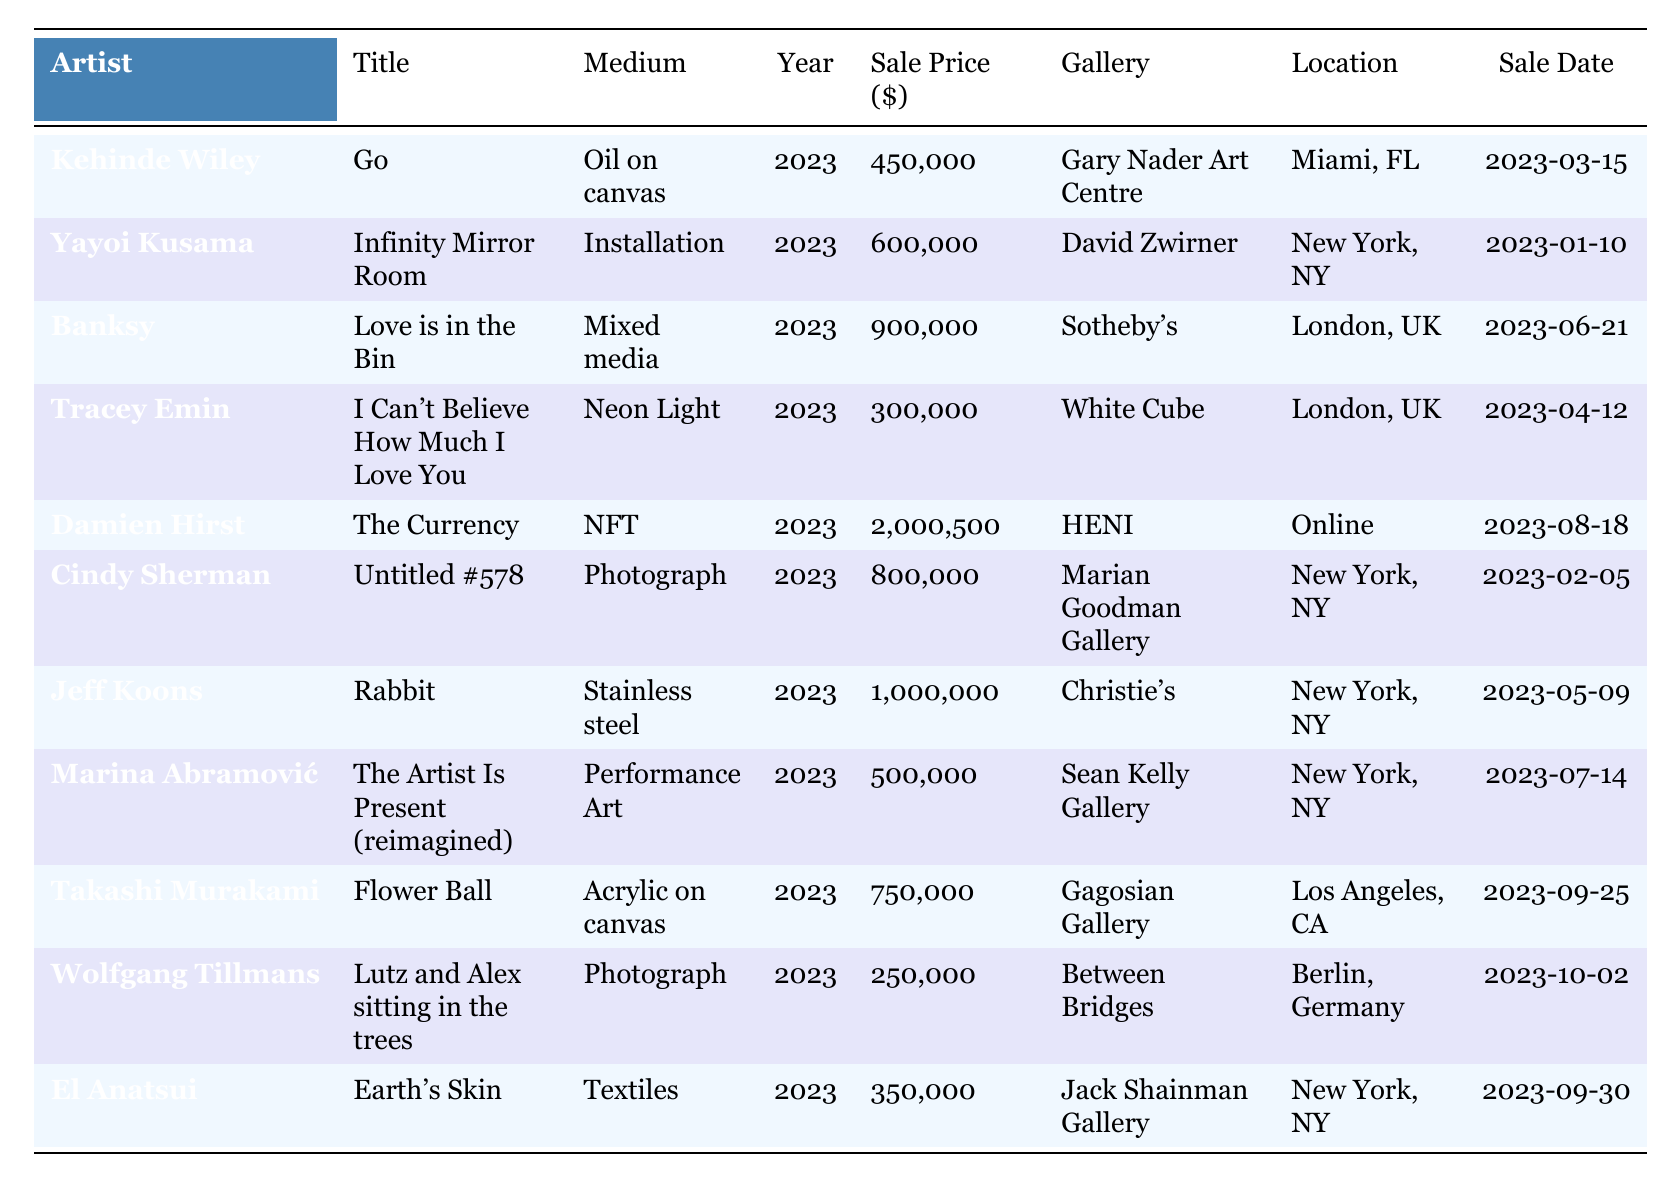What is the title of the artwork sold by Banksy? The table lists all artists along with their corresponding artwork titles. We can directly find that Banksy sold "Love is in the Bin."
Answer: Love is in the Bin Which artwork had the highest sale price, and how much was it? By scanning the sale prices in the table, we see that "The Currency" by Damien Hirst is the highest price at $2,000,500.
Answer: The Currency, $2,000,500 How many artworks were sold for more than $500,000? We look through the sale prices in the table. The following artworks exceed $500,000: "Infinity Mirror Room", "Love is in the Bin", "Untitled #578", "Rabbit", "The Currency", and "Earth's Skin". That's a total of 6 artworks.
Answer: 6 True or False: Yayoi Kusama's artwork was sold in New York. The table shows that Yayoi Kusama's artwork was sold at David Zwirner, which is located in New York, indicating this statement is true.
Answer: True What is the average sale price of the artworks sold in New York? The artworks sold in New York are "Infinity Mirror Room" ($600,000), "Untitled #578" ($800,000), "Rabbit" ($1,000,000), and "The Artist Is Present (reimagined)" ($500,000). The total sale price is 600,000 + 800,000 + 1,000,000 + 500,000 = 2,900,000. There are 4 artworks, so the average is 2,900,000 / 4 = 725,000.
Answer: $725,000 Which gallery sold the most expensive artwork? We review the sales and identify that "The Currency" sold at HENI for $2,000,500, making it the most expensive artwork. Therefore, HENI is the gallery responsible for this highest sale.
Answer: HENI What mediums are represented in the sales of artworks? By examining the table, we note the different mediums: Oil on canvas, Installation, Mixed media, Neon Light, NFT, Photograph, Stainless steel, Performance Art, and Textiles. This gives us a variety of artistic expressions.
Answer: Oil on canvas, Installation, Mixed media, Neon Light, NFT, Photograph, Stainless steel, Performance Art, Textiles How many artworks were sold in London? We check the table for artworks sold in London, which includes "Love is in the Bin" and "I Can't Believe How Much I Love You." That gives us a total of 2 artworks sold in London.
Answer: 2 What is the sale price difference between the artwork by Cindy Sherman and the one by Marina Abramović? Cindy Sherman’s artwork was sold for $800,000, while Marina Abramović's sold for $500,000. The difference is 800,000 - 500,000 = 300,000.
Answer: $300,000 Which artist had a sale date in March and what was their artwork? Looking at the sale dates in the table, Kehinde Wiley's artwork "Go" was sold on March 15, 2023.
Answer: Kehinde Wiley, Go How many artworks had sale prices below $400,000? Checking the sale prices, only one artwork falls below $400,000: "Lutz and Alex sitting in the trees" by Wolfgang Tillmans at $250,000 and "Earth's Skin" by El Anatsui at $350,000. In total, that means 2 artworks were below $400,000.
Answer: 2 